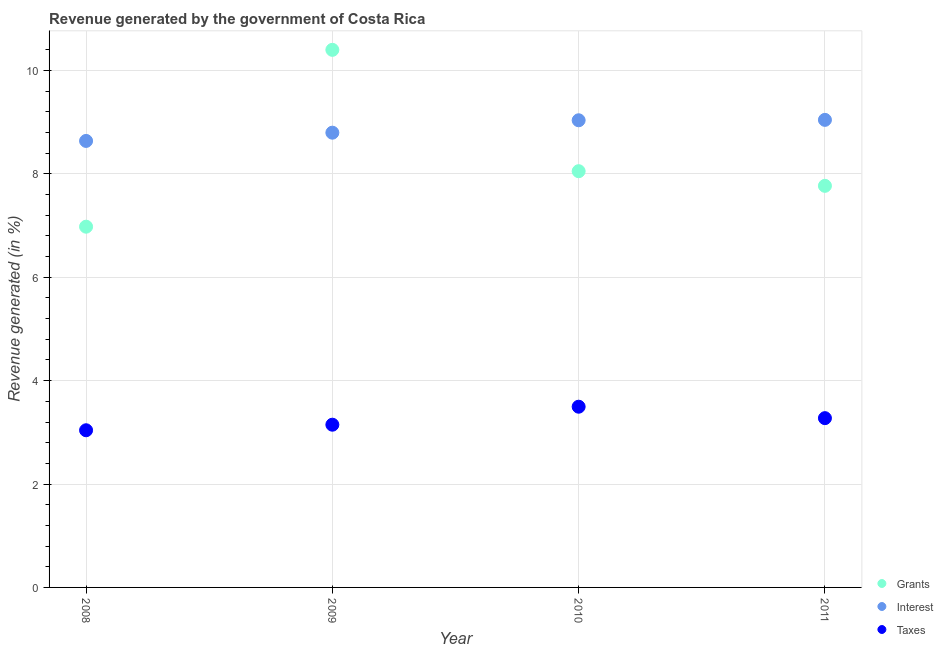What is the percentage of revenue generated by taxes in 2010?
Offer a very short reply. 3.5. Across all years, what is the maximum percentage of revenue generated by interest?
Offer a terse response. 9.04. Across all years, what is the minimum percentage of revenue generated by taxes?
Provide a short and direct response. 3.04. What is the total percentage of revenue generated by grants in the graph?
Ensure brevity in your answer.  33.2. What is the difference between the percentage of revenue generated by interest in 2008 and that in 2009?
Keep it short and to the point. -0.16. What is the difference between the percentage of revenue generated by grants in 2011 and the percentage of revenue generated by taxes in 2008?
Offer a terse response. 4.73. What is the average percentage of revenue generated by taxes per year?
Your answer should be very brief. 3.24. In the year 2011, what is the difference between the percentage of revenue generated by interest and percentage of revenue generated by grants?
Ensure brevity in your answer.  1.28. What is the ratio of the percentage of revenue generated by grants in 2009 to that in 2011?
Offer a very short reply. 1.34. Is the percentage of revenue generated by taxes in 2008 less than that in 2011?
Keep it short and to the point. Yes. Is the difference between the percentage of revenue generated by grants in 2009 and 2010 greater than the difference between the percentage of revenue generated by taxes in 2009 and 2010?
Offer a terse response. Yes. What is the difference between the highest and the second highest percentage of revenue generated by interest?
Provide a succinct answer. 0.01. What is the difference between the highest and the lowest percentage of revenue generated by grants?
Ensure brevity in your answer.  3.42. In how many years, is the percentage of revenue generated by taxes greater than the average percentage of revenue generated by taxes taken over all years?
Keep it short and to the point. 2. Is the sum of the percentage of revenue generated by interest in 2008 and 2011 greater than the maximum percentage of revenue generated by grants across all years?
Keep it short and to the point. Yes. Is it the case that in every year, the sum of the percentage of revenue generated by grants and percentage of revenue generated by interest is greater than the percentage of revenue generated by taxes?
Provide a short and direct response. Yes. Does the percentage of revenue generated by interest monotonically increase over the years?
Offer a terse response. Yes. Is the percentage of revenue generated by grants strictly less than the percentage of revenue generated by taxes over the years?
Provide a succinct answer. No. What is the difference between two consecutive major ticks on the Y-axis?
Your answer should be compact. 2. Are the values on the major ticks of Y-axis written in scientific E-notation?
Give a very brief answer. No. How many legend labels are there?
Your response must be concise. 3. How are the legend labels stacked?
Keep it short and to the point. Vertical. What is the title of the graph?
Offer a terse response. Revenue generated by the government of Costa Rica. What is the label or title of the Y-axis?
Give a very brief answer. Revenue generated (in %). What is the Revenue generated (in %) of Grants in 2008?
Ensure brevity in your answer.  6.98. What is the Revenue generated (in %) of Interest in 2008?
Your answer should be compact. 8.64. What is the Revenue generated (in %) in Taxes in 2008?
Your response must be concise. 3.04. What is the Revenue generated (in %) of Grants in 2009?
Your answer should be very brief. 10.4. What is the Revenue generated (in %) of Interest in 2009?
Provide a short and direct response. 8.8. What is the Revenue generated (in %) in Taxes in 2009?
Your answer should be very brief. 3.15. What is the Revenue generated (in %) in Grants in 2010?
Give a very brief answer. 8.05. What is the Revenue generated (in %) in Interest in 2010?
Your answer should be very brief. 9.04. What is the Revenue generated (in %) of Taxes in 2010?
Your response must be concise. 3.5. What is the Revenue generated (in %) of Grants in 2011?
Provide a short and direct response. 7.77. What is the Revenue generated (in %) of Interest in 2011?
Provide a short and direct response. 9.04. What is the Revenue generated (in %) of Taxes in 2011?
Keep it short and to the point. 3.27. Across all years, what is the maximum Revenue generated (in %) of Grants?
Offer a terse response. 10.4. Across all years, what is the maximum Revenue generated (in %) of Interest?
Ensure brevity in your answer.  9.04. Across all years, what is the maximum Revenue generated (in %) of Taxes?
Offer a terse response. 3.5. Across all years, what is the minimum Revenue generated (in %) of Grants?
Make the answer very short. 6.98. Across all years, what is the minimum Revenue generated (in %) of Interest?
Ensure brevity in your answer.  8.64. Across all years, what is the minimum Revenue generated (in %) in Taxes?
Give a very brief answer. 3.04. What is the total Revenue generated (in %) of Grants in the graph?
Ensure brevity in your answer.  33.2. What is the total Revenue generated (in %) in Interest in the graph?
Keep it short and to the point. 35.51. What is the total Revenue generated (in %) in Taxes in the graph?
Make the answer very short. 12.96. What is the difference between the Revenue generated (in %) of Grants in 2008 and that in 2009?
Give a very brief answer. -3.42. What is the difference between the Revenue generated (in %) in Interest in 2008 and that in 2009?
Provide a short and direct response. -0.16. What is the difference between the Revenue generated (in %) in Taxes in 2008 and that in 2009?
Your answer should be compact. -0.11. What is the difference between the Revenue generated (in %) in Grants in 2008 and that in 2010?
Ensure brevity in your answer.  -1.07. What is the difference between the Revenue generated (in %) in Interest in 2008 and that in 2010?
Keep it short and to the point. -0.4. What is the difference between the Revenue generated (in %) in Taxes in 2008 and that in 2010?
Provide a succinct answer. -0.46. What is the difference between the Revenue generated (in %) of Grants in 2008 and that in 2011?
Ensure brevity in your answer.  -0.79. What is the difference between the Revenue generated (in %) in Interest in 2008 and that in 2011?
Make the answer very short. -0.41. What is the difference between the Revenue generated (in %) in Taxes in 2008 and that in 2011?
Provide a succinct answer. -0.23. What is the difference between the Revenue generated (in %) in Grants in 2009 and that in 2010?
Offer a terse response. 2.35. What is the difference between the Revenue generated (in %) of Interest in 2009 and that in 2010?
Provide a succinct answer. -0.24. What is the difference between the Revenue generated (in %) of Taxes in 2009 and that in 2010?
Provide a succinct answer. -0.35. What is the difference between the Revenue generated (in %) of Grants in 2009 and that in 2011?
Your answer should be compact. 2.63. What is the difference between the Revenue generated (in %) of Interest in 2009 and that in 2011?
Your answer should be very brief. -0.25. What is the difference between the Revenue generated (in %) of Taxes in 2009 and that in 2011?
Provide a succinct answer. -0.13. What is the difference between the Revenue generated (in %) in Grants in 2010 and that in 2011?
Ensure brevity in your answer.  0.28. What is the difference between the Revenue generated (in %) in Interest in 2010 and that in 2011?
Your response must be concise. -0.01. What is the difference between the Revenue generated (in %) of Taxes in 2010 and that in 2011?
Keep it short and to the point. 0.22. What is the difference between the Revenue generated (in %) of Grants in 2008 and the Revenue generated (in %) of Interest in 2009?
Ensure brevity in your answer.  -1.82. What is the difference between the Revenue generated (in %) of Grants in 2008 and the Revenue generated (in %) of Taxes in 2009?
Your answer should be very brief. 3.83. What is the difference between the Revenue generated (in %) of Interest in 2008 and the Revenue generated (in %) of Taxes in 2009?
Make the answer very short. 5.49. What is the difference between the Revenue generated (in %) of Grants in 2008 and the Revenue generated (in %) of Interest in 2010?
Your response must be concise. -2.06. What is the difference between the Revenue generated (in %) of Grants in 2008 and the Revenue generated (in %) of Taxes in 2010?
Provide a succinct answer. 3.48. What is the difference between the Revenue generated (in %) in Interest in 2008 and the Revenue generated (in %) in Taxes in 2010?
Make the answer very short. 5.14. What is the difference between the Revenue generated (in %) of Grants in 2008 and the Revenue generated (in %) of Interest in 2011?
Keep it short and to the point. -2.07. What is the difference between the Revenue generated (in %) of Grants in 2008 and the Revenue generated (in %) of Taxes in 2011?
Your answer should be very brief. 3.7. What is the difference between the Revenue generated (in %) in Interest in 2008 and the Revenue generated (in %) in Taxes in 2011?
Provide a short and direct response. 5.36. What is the difference between the Revenue generated (in %) of Grants in 2009 and the Revenue generated (in %) of Interest in 2010?
Provide a succinct answer. 1.36. What is the difference between the Revenue generated (in %) of Grants in 2009 and the Revenue generated (in %) of Taxes in 2010?
Give a very brief answer. 6.9. What is the difference between the Revenue generated (in %) of Interest in 2009 and the Revenue generated (in %) of Taxes in 2010?
Provide a succinct answer. 5.3. What is the difference between the Revenue generated (in %) of Grants in 2009 and the Revenue generated (in %) of Interest in 2011?
Ensure brevity in your answer.  1.35. What is the difference between the Revenue generated (in %) of Grants in 2009 and the Revenue generated (in %) of Taxes in 2011?
Offer a very short reply. 7.12. What is the difference between the Revenue generated (in %) of Interest in 2009 and the Revenue generated (in %) of Taxes in 2011?
Your answer should be compact. 5.52. What is the difference between the Revenue generated (in %) of Grants in 2010 and the Revenue generated (in %) of Interest in 2011?
Keep it short and to the point. -0.99. What is the difference between the Revenue generated (in %) of Grants in 2010 and the Revenue generated (in %) of Taxes in 2011?
Offer a terse response. 4.78. What is the difference between the Revenue generated (in %) of Interest in 2010 and the Revenue generated (in %) of Taxes in 2011?
Provide a short and direct response. 5.76. What is the average Revenue generated (in %) of Grants per year?
Offer a very short reply. 8.3. What is the average Revenue generated (in %) in Interest per year?
Make the answer very short. 8.88. What is the average Revenue generated (in %) in Taxes per year?
Your answer should be very brief. 3.24. In the year 2008, what is the difference between the Revenue generated (in %) of Grants and Revenue generated (in %) of Interest?
Keep it short and to the point. -1.66. In the year 2008, what is the difference between the Revenue generated (in %) of Grants and Revenue generated (in %) of Taxes?
Offer a very short reply. 3.94. In the year 2008, what is the difference between the Revenue generated (in %) of Interest and Revenue generated (in %) of Taxes?
Your answer should be very brief. 5.6. In the year 2009, what is the difference between the Revenue generated (in %) in Grants and Revenue generated (in %) in Interest?
Make the answer very short. 1.6. In the year 2009, what is the difference between the Revenue generated (in %) of Grants and Revenue generated (in %) of Taxes?
Your answer should be compact. 7.25. In the year 2009, what is the difference between the Revenue generated (in %) of Interest and Revenue generated (in %) of Taxes?
Offer a terse response. 5.65. In the year 2010, what is the difference between the Revenue generated (in %) of Grants and Revenue generated (in %) of Interest?
Your response must be concise. -0.98. In the year 2010, what is the difference between the Revenue generated (in %) of Grants and Revenue generated (in %) of Taxes?
Ensure brevity in your answer.  4.56. In the year 2010, what is the difference between the Revenue generated (in %) in Interest and Revenue generated (in %) in Taxes?
Your response must be concise. 5.54. In the year 2011, what is the difference between the Revenue generated (in %) of Grants and Revenue generated (in %) of Interest?
Your answer should be very brief. -1.28. In the year 2011, what is the difference between the Revenue generated (in %) of Grants and Revenue generated (in %) of Taxes?
Offer a terse response. 4.49. In the year 2011, what is the difference between the Revenue generated (in %) of Interest and Revenue generated (in %) of Taxes?
Keep it short and to the point. 5.77. What is the ratio of the Revenue generated (in %) in Grants in 2008 to that in 2009?
Provide a short and direct response. 0.67. What is the ratio of the Revenue generated (in %) of Interest in 2008 to that in 2009?
Offer a terse response. 0.98. What is the ratio of the Revenue generated (in %) in Taxes in 2008 to that in 2009?
Make the answer very short. 0.97. What is the ratio of the Revenue generated (in %) in Grants in 2008 to that in 2010?
Your answer should be very brief. 0.87. What is the ratio of the Revenue generated (in %) of Interest in 2008 to that in 2010?
Provide a succinct answer. 0.96. What is the ratio of the Revenue generated (in %) of Taxes in 2008 to that in 2010?
Your response must be concise. 0.87. What is the ratio of the Revenue generated (in %) in Grants in 2008 to that in 2011?
Offer a very short reply. 0.9. What is the ratio of the Revenue generated (in %) of Interest in 2008 to that in 2011?
Your answer should be compact. 0.95. What is the ratio of the Revenue generated (in %) of Taxes in 2008 to that in 2011?
Make the answer very short. 0.93. What is the ratio of the Revenue generated (in %) in Grants in 2009 to that in 2010?
Your response must be concise. 1.29. What is the ratio of the Revenue generated (in %) of Interest in 2009 to that in 2010?
Ensure brevity in your answer.  0.97. What is the ratio of the Revenue generated (in %) in Taxes in 2009 to that in 2010?
Give a very brief answer. 0.9. What is the ratio of the Revenue generated (in %) of Grants in 2009 to that in 2011?
Make the answer very short. 1.34. What is the ratio of the Revenue generated (in %) of Interest in 2009 to that in 2011?
Your response must be concise. 0.97. What is the ratio of the Revenue generated (in %) in Taxes in 2009 to that in 2011?
Provide a succinct answer. 0.96. What is the ratio of the Revenue generated (in %) of Grants in 2010 to that in 2011?
Provide a succinct answer. 1.04. What is the ratio of the Revenue generated (in %) in Interest in 2010 to that in 2011?
Your response must be concise. 1. What is the ratio of the Revenue generated (in %) of Taxes in 2010 to that in 2011?
Provide a succinct answer. 1.07. What is the difference between the highest and the second highest Revenue generated (in %) of Grants?
Your answer should be very brief. 2.35. What is the difference between the highest and the second highest Revenue generated (in %) in Interest?
Your answer should be very brief. 0.01. What is the difference between the highest and the second highest Revenue generated (in %) in Taxes?
Ensure brevity in your answer.  0.22. What is the difference between the highest and the lowest Revenue generated (in %) of Grants?
Provide a succinct answer. 3.42. What is the difference between the highest and the lowest Revenue generated (in %) in Interest?
Make the answer very short. 0.41. What is the difference between the highest and the lowest Revenue generated (in %) of Taxes?
Offer a very short reply. 0.46. 